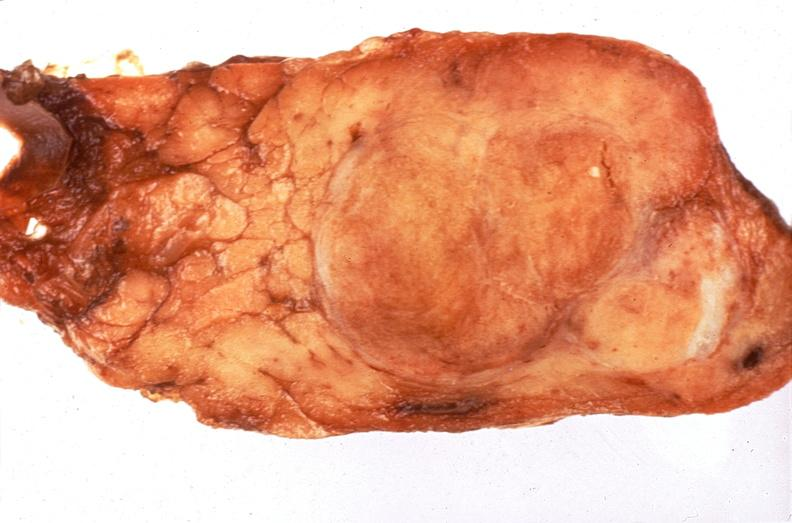what is present?
Answer the question using a single word or phrase. Endocrine 